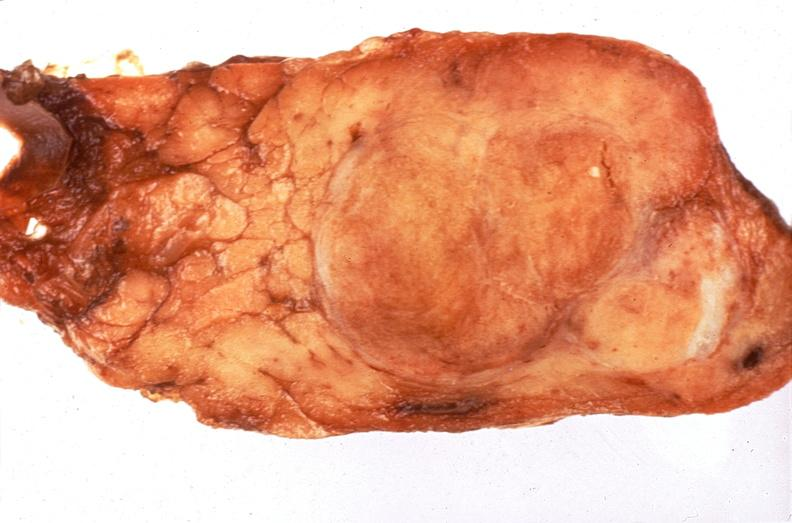what is present?
Answer the question using a single word or phrase. Endocrine 